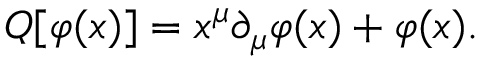Convert formula to latex. <formula><loc_0><loc_0><loc_500><loc_500>Q [ \varphi ( x ) ] = x ^ { \mu } \partial _ { \mu } \varphi ( x ) + \varphi ( x ) .</formula> 